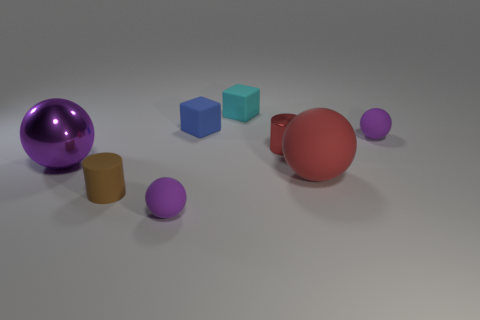Add 1 small spheres. How many objects exist? 9 Subtract all large purple metallic balls. How many balls are left? 3 Subtract all red spheres. How many spheres are left? 3 Subtract all cylinders. How many objects are left? 6 Subtract 3 spheres. How many spheres are left? 1 Subtract all green spheres. Subtract all green blocks. How many spheres are left? 4 Subtract all green blocks. How many blue cylinders are left? 0 Subtract all brown rubber things. Subtract all red metallic objects. How many objects are left? 6 Add 2 brown things. How many brown things are left? 3 Add 3 brown matte cylinders. How many brown matte cylinders exist? 4 